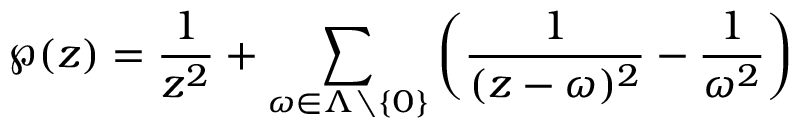<formula> <loc_0><loc_0><loc_500><loc_500>\wp ( z ) = { \frac { 1 } { z ^ { 2 } } } + \sum _ { \omega \in \Lambda \ \left \{ 0 \right \} } \left ( { \frac { 1 } { ( z - \omega ) ^ { 2 } } } - { \frac { 1 } { \omega ^ { 2 } } } \right )</formula> 